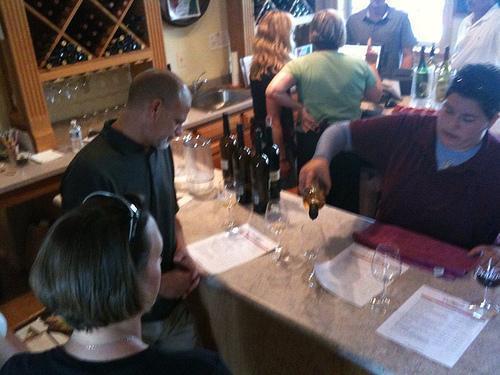What kind of wine is the man serving in the glasses?
Select the accurate response from the four choices given to answer the question.
Options: Red, orange, pink, white. White. 